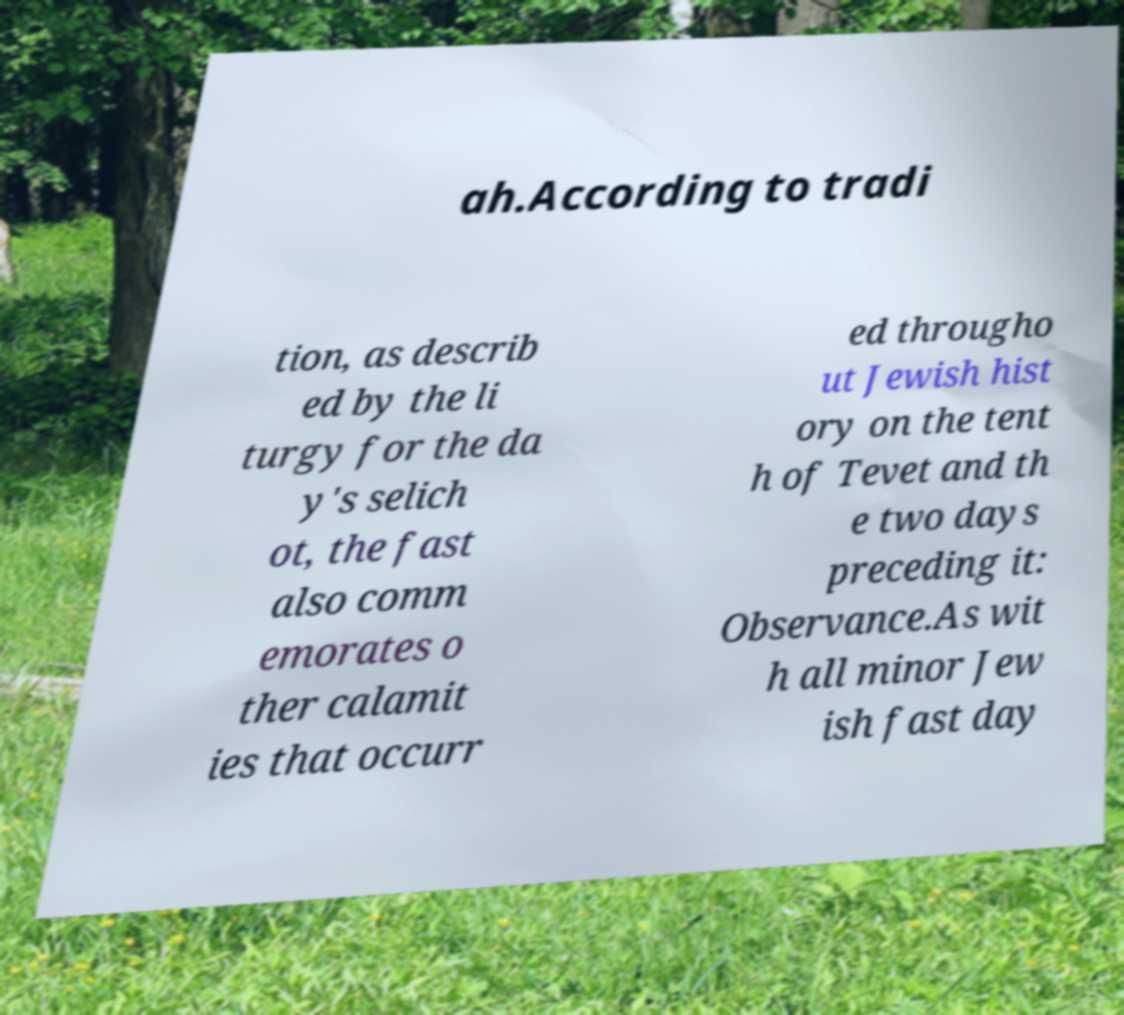I need the written content from this picture converted into text. Can you do that? ah.According to tradi tion, as describ ed by the li turgy for the da y's selich ot, the fast also comm emorates o ther calamit ies that occurr ed througho ut Jewish hist ory on the tent h of Tevet and th e two days preceding it: Observance.As wit h all minor Jew ish fast day 